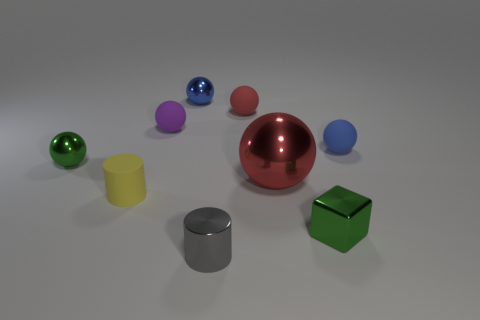How many objects in the image have reflective surfaces? There are three objects in the image that have highly reflective surfaces. These are the red sphere, the silver cylinder, and the smaller blue sphere. Can you tell me if the light source is depicted within the image or if it's implied? The light source is not explicitly shown in the image. However, reflections and shadows on and around the objects suggest a light source coming from the top left, outside the frame of the image. 